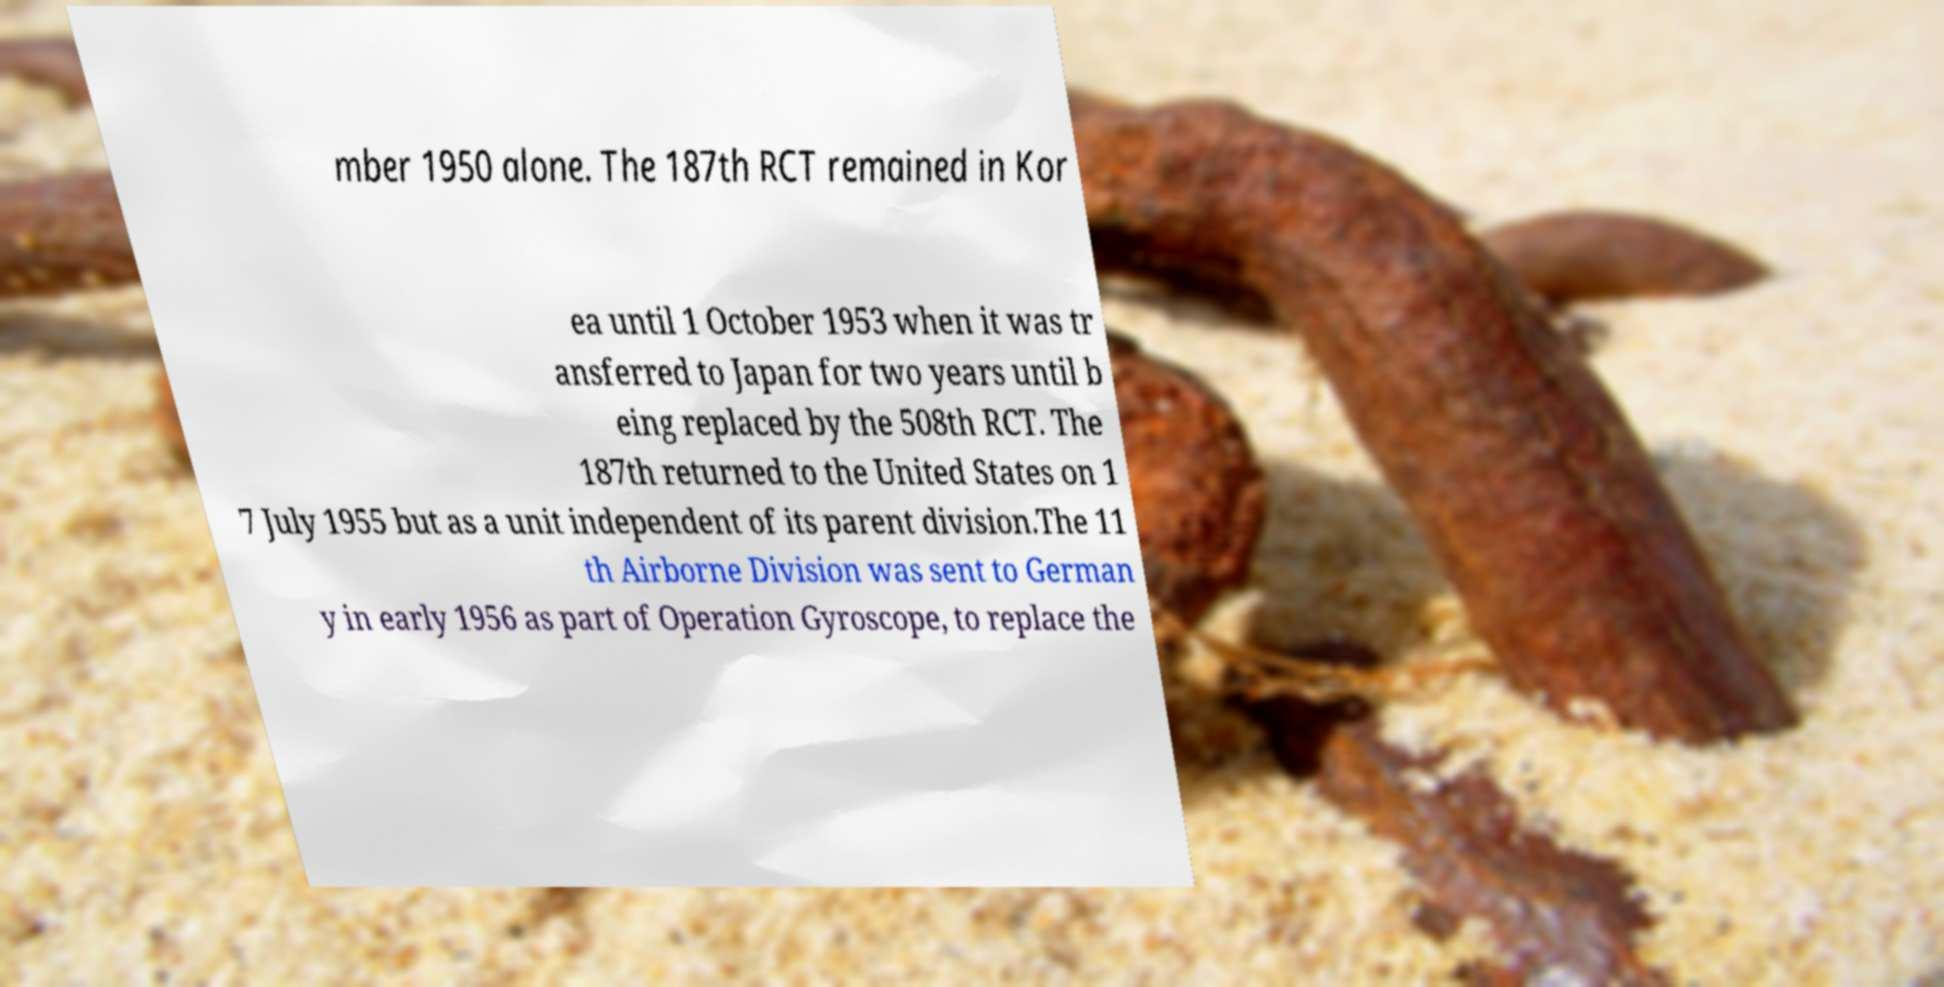Please identify and transcribe the text found in this image. mber 1950 alone. The 187th RCT remained in Kor ea until 1 October 1953 when it was tr ansferred to Japan for two years until b eing replaced by the 508th RCT. The 187th returned to the United States on 1 7 July 1955 but as a unit independent of its parent division.The 11 th Airborne Division was sent to German y in early 1956 as part of Operation Gyroscope, to replace the 